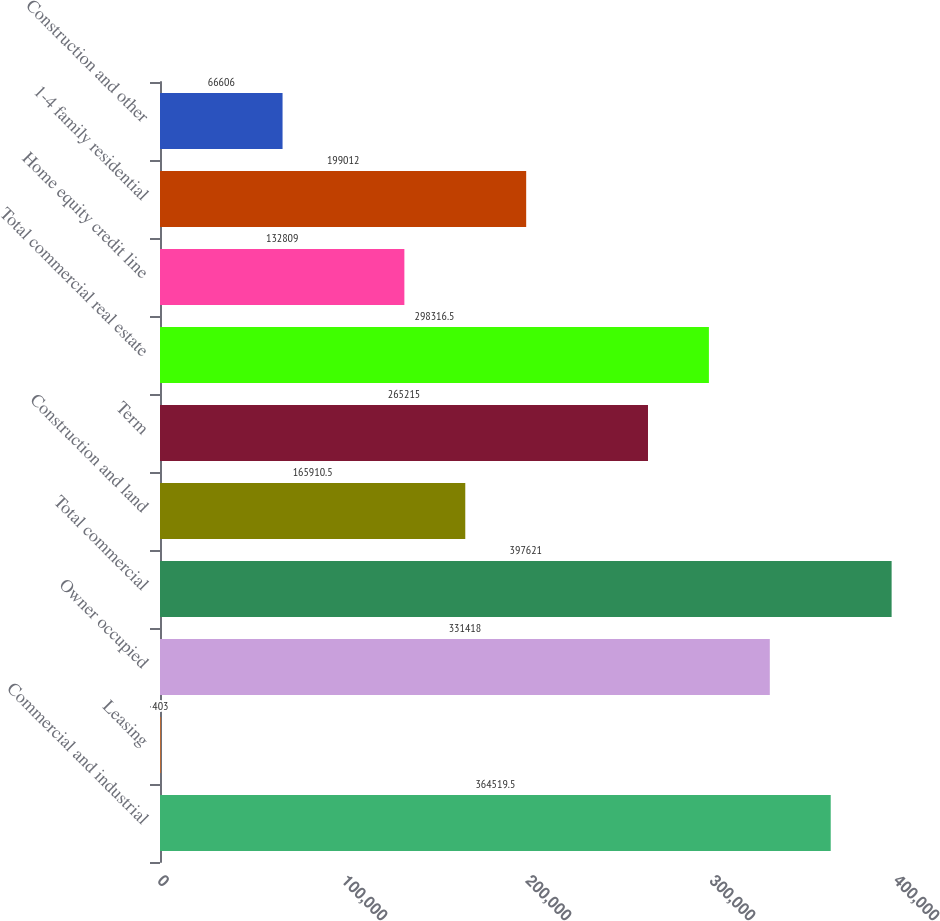<chart> <loc_0><loc_0><loc_500><loc_500><bar_chart><fcel>Commercial and industrial<fcel>Leasing<fcel>Owner occupied<fcel>Total commercial<fcel>Construction and land<fcel>Term<fcel>Total commercial real estate<fcel>Home equity credit line<fcel>1-4 family residential<fcel>Construction and other<nl><fcel>364520<fcel>403<fcel>331418<fcel>397621<fcel>165910<fcel>265215<fcel>298316<fcel>132809<fcel>199012<fcel>66606<nl></chart> 